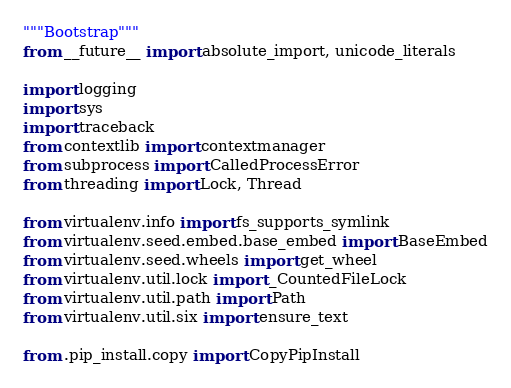Convert code to text. <code><loc_0><loc_0><loc_500><loc_500><_Python_>"""Bootstrap"""
from __future__ import absolute_import, unicode_literals

import logging
import sys
import traceback
from contextlib import contextmanager
from subprocess import CalledProcessError
from threading import Lock, Thread

from virtualenv.info import fs_supports_symlink
from virtualenv.seed.embed.base_embed import BaseEmbed
from virtualenv.seed.wheels import get_wheel
from virtualenv.util.lock import _CountedFileLock
from virtualenv.util.path import Path
from virtualenv.util.six import ensure_text

from .pip_install.copy import CopyPipInstall</code> 